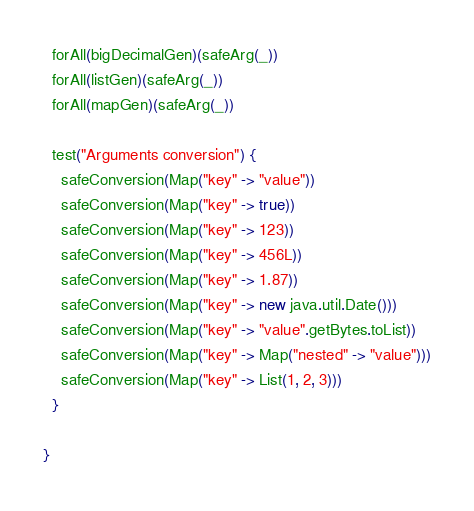<code> <loc_0><loc_0><loc_500><loc_500><_Scala_>  forAll(bigDecimalGen)(safeArg(_))
  forAll(listGen)(safeArg(_))
  forAll(mapGen)(safeArg(_))

  test("Arguments conversion") {
    safeConversion(Map("key" -> "value"))
    safeConversion(Map("key" -> true))
    safeConversion(Map("key" -> 123))
    safeConversion(Map("key" -> 456L))
    safeConversion(Map("key" -> 1.87))
    safeConversion(Map("key" -> new java.util.Date()))
    safeConversion(Map("key" -> "value".getBytes.toList))
    safeConversion(Map("key" -> Map("nested" -> "value")))
    safeConversion(Map("key" -> List(1, 2, 3)))
  }

}
</code> 